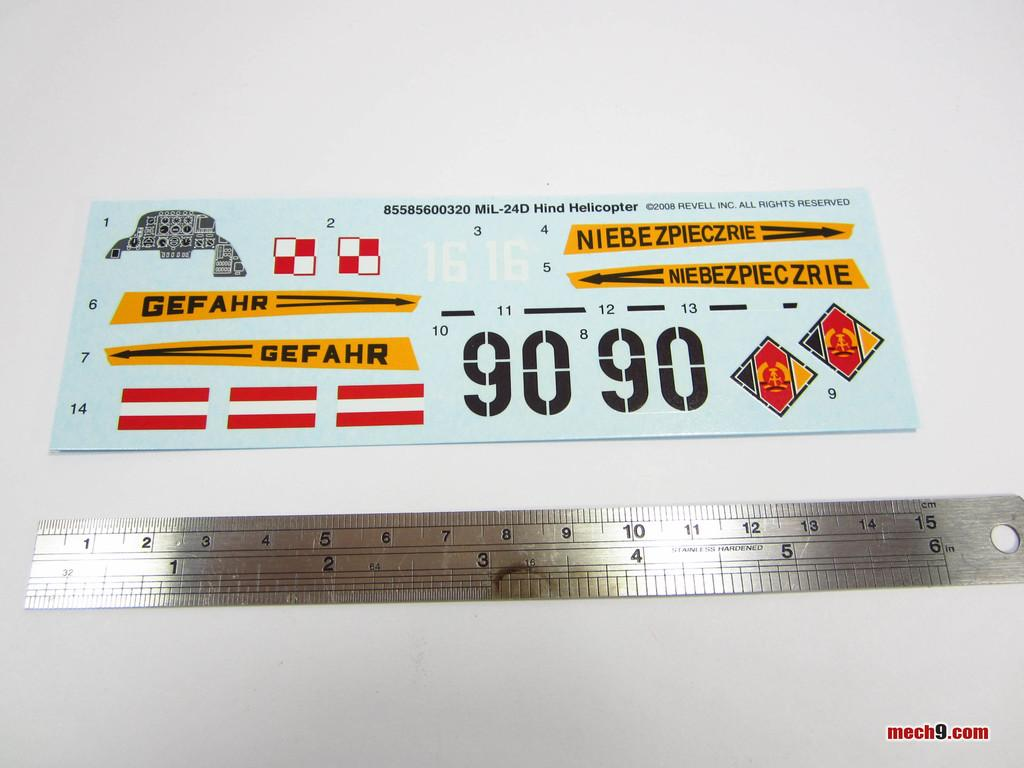<image>
Offer a succinct explanation of the picture presented. A sheet of decals for a Revell Hind Helicopter is laying next to a 6 inch ruler. 